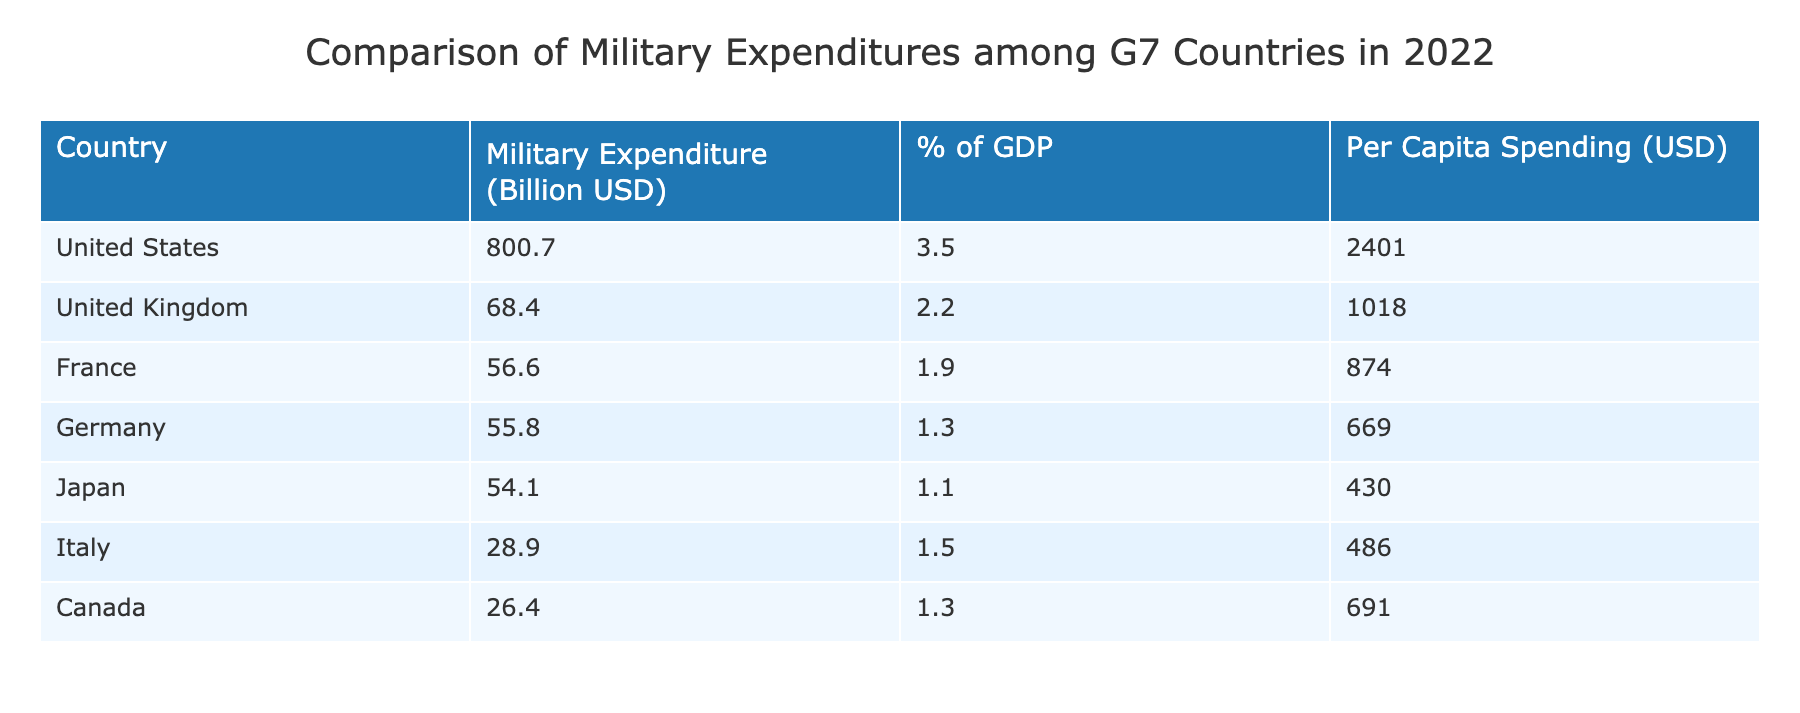What is the military expenditure of the United States in 2022? The table lists the military expenditure for each G7 country in billions of USD. For the United States, the figure is directly specified in the table as 800.7 billion USD.
Answer: 800.7 billion USD Which country has the lowest per capita spending on military in 2022? The per capita spending is shown in the table for each country. By comparing the values, Japan has the lowest at 430 USD.
Answer: Japan What is the total military expenditure of Canada and Italy combined? To find this, we need to sum the military expenditures of both countries from the table. Canada has 26.4 billion USD and Italy has 28.9 billion USD. Adding these gives us 26.4 + 28.9 = 55.3 billion USD.
Answer: 55.3 billion USD Is it true that Germany's military expenditure is greater than Japan's? Looking at the military expenditures listed in the table, Germany's is 55.8 billion USD, while Japan's is 54.1 billion USD. Therefore, it is true that Germany's expenditure is greater than Japan's.
Answer: Yes What is the average military spending as a percentage of GDP across the G7 countries? First, we find the percentage of GDP for each country and add them: 3.5 + 2.2 + 1.9 + 1.3 + 1.1 + 1.5 + 1.3 = 12.8. Then, divide this by the number of countries (7) to find the average: 12.8 / 7 = 1.829.
Answer: 1.83% How much more is the military expenditure of the United States compared to that of France? From the table, the military expenditure of the United States is 800.7 billion USD, and for France, it is 56.6 billion USD. To find the difference, subtract France's figure from the United States': 800.7 - 56.6 = 744.1 billion USD.
Answer: 744.1 billion USD Do all G7 countries spend more than 1% of their GDP on military expenditure? The table shows the percentage of GDP for each G7 country. By examining these percentages, we find that Germany (1.3%) and Japan (1.1%) are below 1.5%. Therefore, not all G7 countries meet this criterion.
Answer: No Which G7 country spends the most on military per capita? The table provides per capita spending for each country. By comparing these values, the United States has the highest per capita spending at 2401 USD.
Answer: United States 